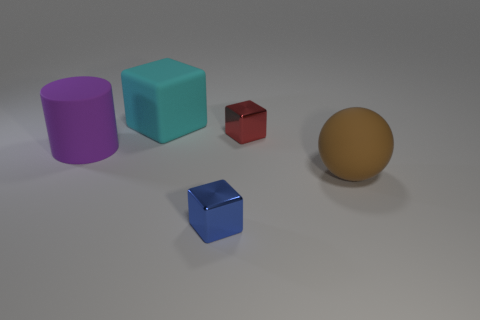Can you tell me what shapes and colors are represented in this image? Certainly! The image features a collection of geometric shapes that include a purple cylinder, a cyan cube, a mini red cube, a small blue cube, and a tan sphere. The arrangement and the colors chosen have a modern, minimalist aesthetic. Is there any significance to the arrangement of these objects? The objects seem to be arranged purposefully, possibly to showcase contrast in both size and color. It's almost an abstract composition, allowing us to appreciate the simplicity of form and how colors interact with one another in a three-dimensional space. 